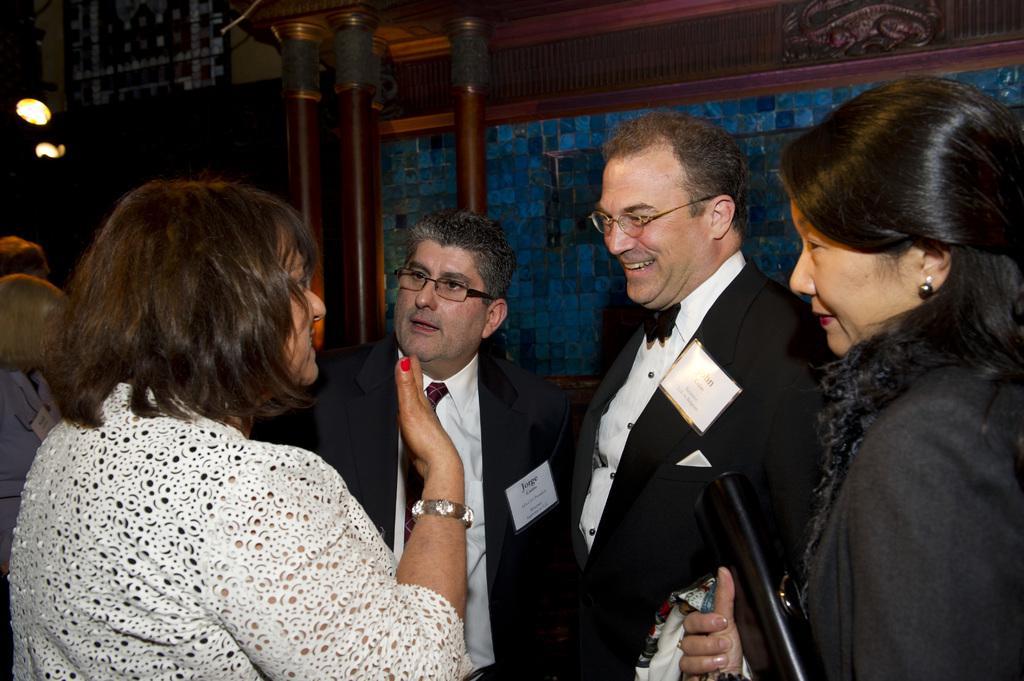Describe this image in one or two sentences. In this image we can see two men wearing blazers and two women are standing here. In the background, we can see a few more people, the wall, pillars and the lights here. 